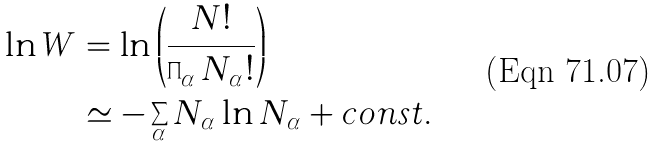Convert formula to latex. <formula><loc_0><loc_0><loc_500><loc_500>\ln W & = \ln \left ( \frac { N ! } { \prod _ { \alpha } N _ { \alpha } ! } \right ) \\ & \simeq - \sum _ { \alpha } N _ { \alpha } \ln N _ { \alpha } + c o n s t .</formula> 